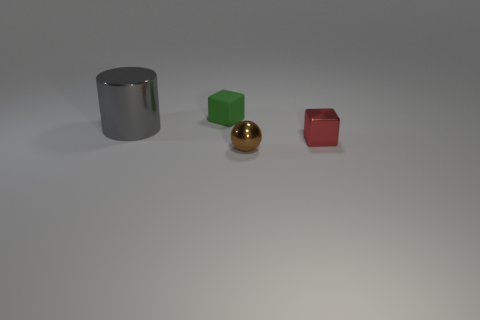The metal object that is the same shape as the green rubber object is what size?
Give a very brief answer. Small. Are the gray cylinder and the red cube made of the same material?
Keep it short and to the point. Yes. How many tiny balls are behind the small thing behind the big object?
Provide a short and direct response. 0. What number of red objects are blocks or large metal objects?
Your response must be concise. 1. The tiny object behind the large thing that is on the left side of the block that is to the right of the matte block is what shape?
Your answer should be very brief. Cube. What color is the matte thing that is the same size as the brown shiny thing?
Your answer should be very brief. Green. How many brown objects have the same shape as the red metal thing?
Give a very brief answer. 0. There is a sphere; is its size the same as the thing that is on the left side of the green block?
Offer a very short reply. No. What shape is the metallic object right of the tiny metal object that is in front of the red metallic object?
Make the answer very short. Cube. Is the number of big metal cylinders behind the tiny green block less than the number of large gray metallic cylinders?
Your answer should be compact. Yes. 